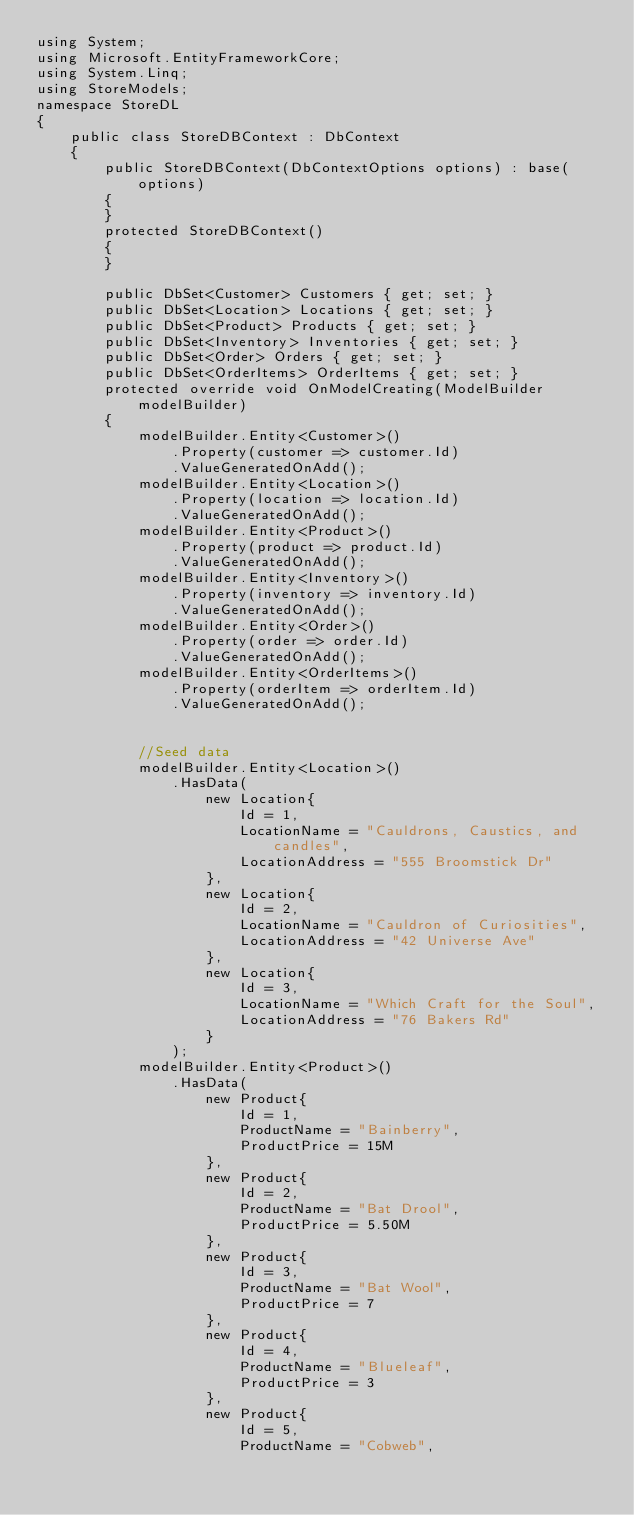<code> <loc_0><loc_0><loc_500><loc_500><_C#_>using System;
using Microsoft.EntityFrameworkCore;
using System.Linq;
using StoreModels;
namespace StoreDL
{
    public class StoreDBContext : DbContext
    {
        public StoreDBContext(DbContextOptions options) : base(options)
        {
        }
        protected StoreDBContext()
        {
        }

        public DbSet<Customer> Customers { get; set; }
        public DbSet<Location> Locations { get; set; }
        public DbSet<Product> Products { get; set; }
        public DbSet<Inventory> Inventories { get; set; }
        public DbSet<Order> Orders { get; set; }
        public DbSet<OrderItems> OrderItems { get; set; }
        protected override void OnModelCreating(ModelBuilder modelBuilder)
        {
            modelBuilder.Entity<Customer>()
                .Property(customer => customer.Id)
                .ValueGeneratedOnAdd();
            modelBuilder.Entity<Location>()
                .Property(location => location.Id)
                .ValueGeneratedOnAdd();
            modelBuilder.Entity<Product>()
                .Property(product => product.Id)
                .ValueGeneratedOnAdd();
            modelBuilder.Entity<Inventory>()
                .Property(inventory => inventory.Id)
                .ValueGeneratedOnAdd();
            modelBuilder.Entity<Order>()
                .Property(order => order.Id)
                .ValueGeneratedOnAdd();
            modelBuilder.Entity<OrderItems>()
                .Property(orderItem => orderItem.Id)
                .ValueGeneratedOnAdd();
            
            
            //Seed data
            modelBuilder.Entity<Location>()
                .HasData(
                    new Location{
                        Id = 1,
                        LocationName = "Cauldrons, Caustics, and candles",
                        LocationAddress = "555 Broomstick Dr"
                    },
                    new Location{
                        Id = 2,
                        LocationName = "Cauldron of Curiosities",
                        LocationAddress = "42 Universe Ave"
                    },
                    new Location{
                        Id = 3,
                        LocationName = "Which Craft for the Soul",
                        LocationAddress = "76 Bakers Rd"
                    }
                );
            modelBuilder.Entity<Product>()
                .HasData(
                    new Product{
                        Id = 1,
                        ProductName = "Bainberry",
                        ProductPrice = 15M
                    },
                    new Product{
                        Id = 2,
                        ProductName = "Bat Drool",
                        ProductPrice = 5.50M
                    },
                    new Product{
                        Id = 3,
                        ProductName = "Bat Wool",
                        ProductPrice = 7
                    },
                    new Product{
                        Id = 4,
                        ProductName = "Blueleaf",
                        ProductPrice = 3
                    },
                    new Product{
                        Id = 5,
                        ProductName = "Cobweb",</code> 